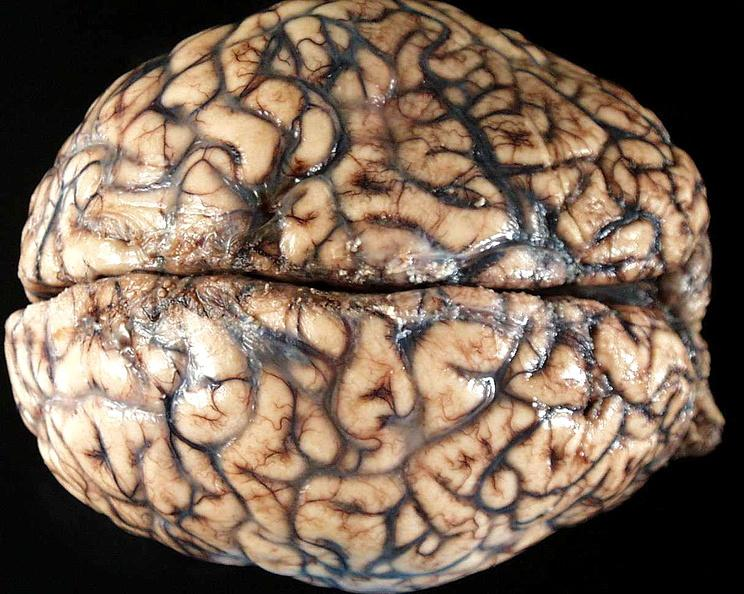s choanal patency present?
Answer the question using a single word or phrase. No 